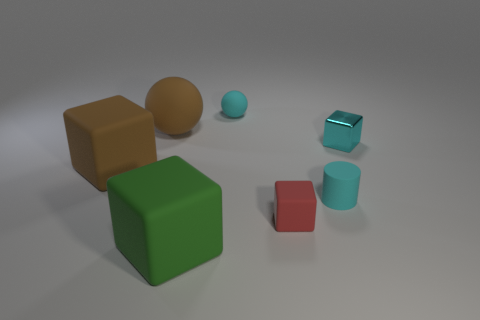What material do the objects in the image seem to be made of? The objects in the image appear to have a matte finish, suggesting they are likely made of a plastic or perhaps a clay material that does not have a reflective surface. 